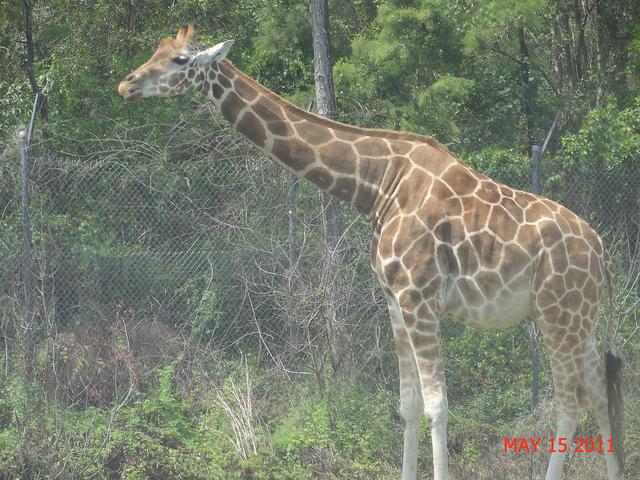Are the giraffe's legs straight?
Write a very short answer. Yes. How many different animals are shown?
Write a very short answer. 1. Is the giraffe in its natural habitat or captivity?
Answer briefly. Captivity. What month was this picture taken in?
Answer briefly. May. Is the giraffe taller than the fence?
Quick response, please. Yes. 